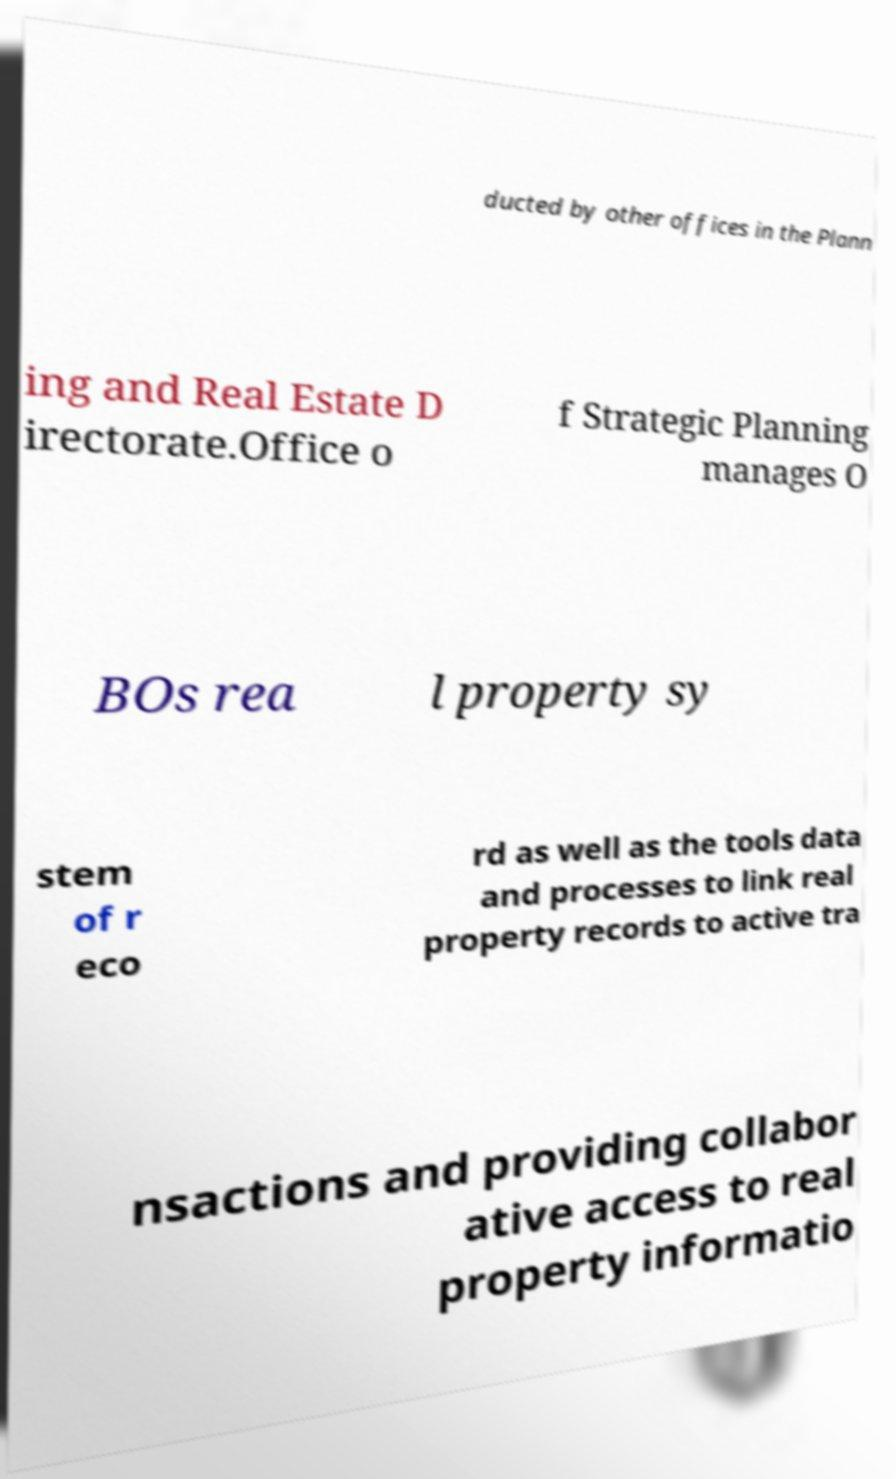Can you read and provide the text displayed in the image?This photo seems to have some interesting text. Can you extract and type it out for me? ducted by other offices in the Plann ing and Real Estate D irectorate.Office o f Strategic Planning manages O BOs rea l property sy stem of r eco rd as well as the tools data and processes to link real property records to active tra nsactions and providing collabor ative access to real property informatio 